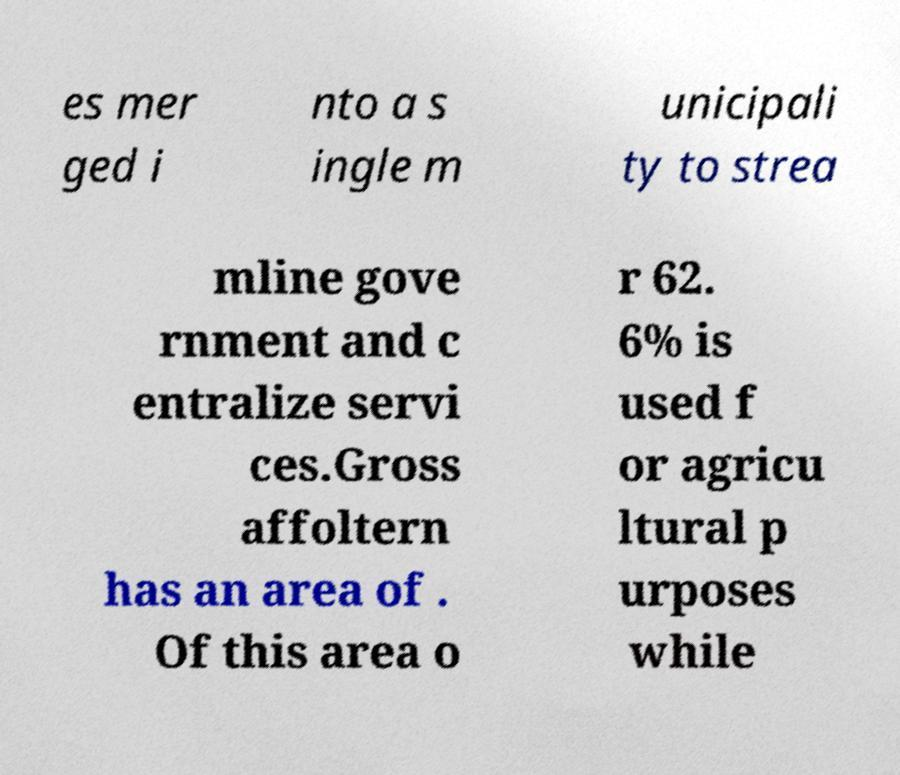I need the written content from this picture converted into text. Can you do that? es mer ged i nto a s ingle m unicipali ty to strea mline gove rnment and c entralize servi ces.Gross affoltern has an area of . Of this area o r 62. 6% is used f or agricu ltural p urposes while 